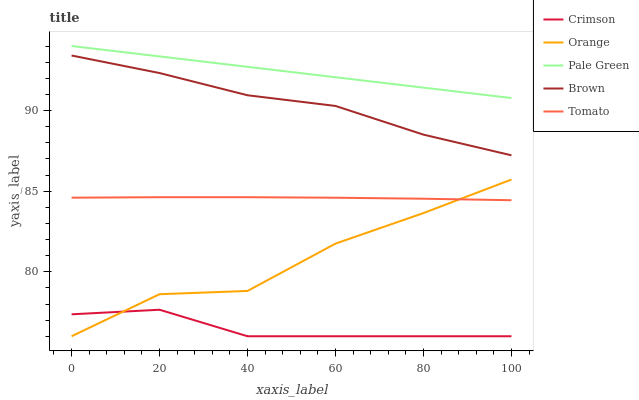Does Crimson have the minimum area under the curve?
Answer yes or no. Yes. Does Pale Green have the maximum area under the curve?
Answer yes or no. Yes. Does Orange have the minimum area under the curve?
Answer yes or no. No. Does Orange have the maximum area under the curve?
Answer yes or no. No. Is Pale Green the smoothest?
Answer yes or no. Yes. Is Orange the roughest?
Answer yes or no. Yes. Is Tomato the smoothest?
Answer yes or no. No. Is Tomato the roughest?
Answer yes or no. No. Does Crimson have the lowest value?
Answer yes or no. Yes. Does Tomato have the lowest value?
Answer yes or no. No. Does Pale Green have the highest value?
Answer yes or no. Yes. Does Orange have the highest value?
Answer yes or no. No. Is Tomato less than Pale Green?
Answer yes or no. Yes. Is Brown greater than Tomato?
Answer yes or no. Yes. Does Crimson intersect Orange?
Answer yes or no. Yes. Is Crimson less than Orange?
Answer yes or no. No. Is Crimson greater than Orange?
Answer yes or no. No. Does Tomato intersect Pale Green?
Answer yes or no. No. 